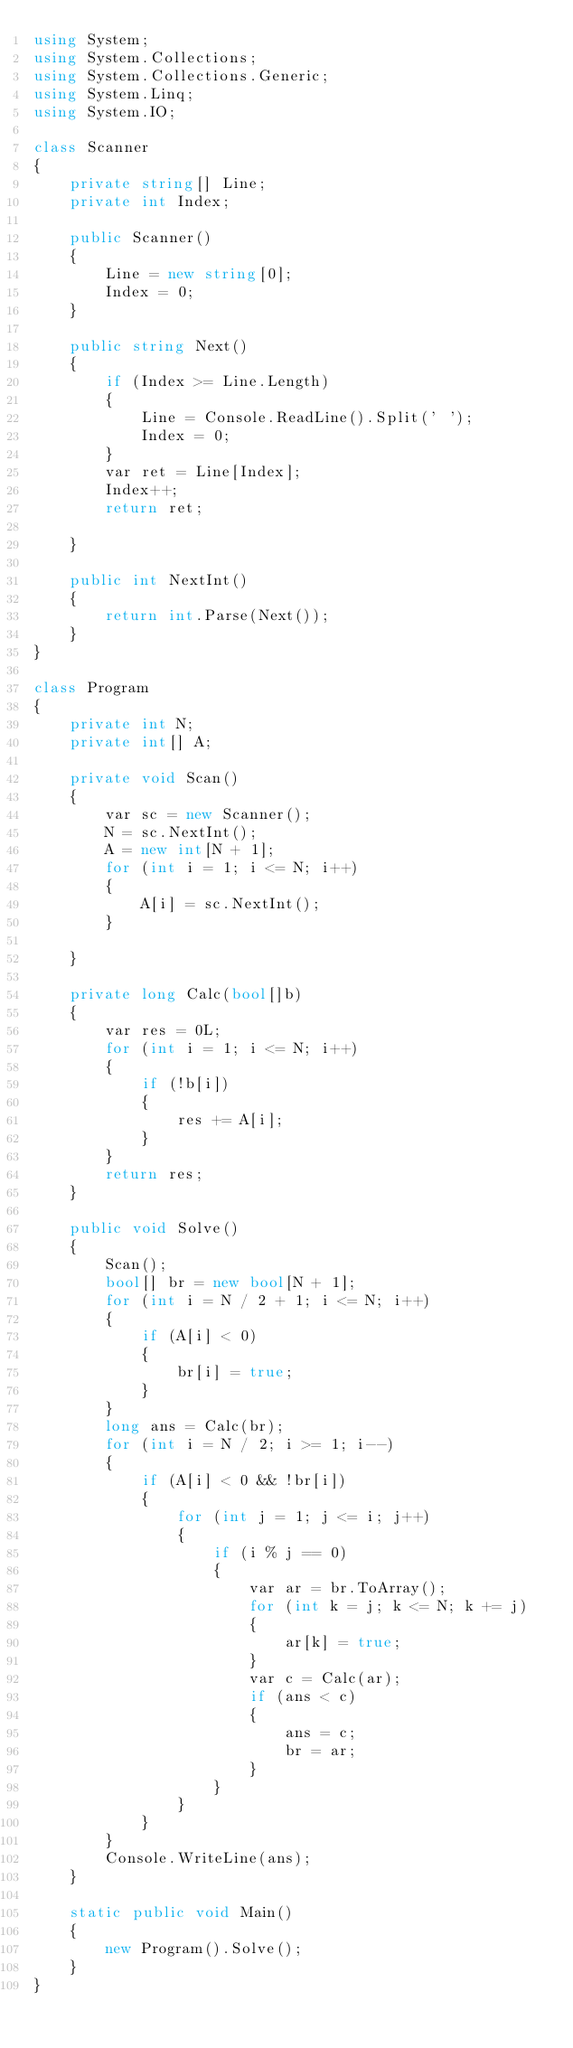<code> <loc_0><loc_0><loc_500><loc_500><_C#_>using System;
using System.Collections;
using System.Collections.Generic;
using System.Linq;
using System.IO;

class Scanner
{
    private string[] Line;
    private int Index;

    public Scanner()
    {
        Line = new string[0];
        Index = 0;
    }

    public string Next()
    {
        if (Index >= Line.Length)
        {
            Line = Console.ReadLine().Split(' ');
            Index = 0;
        }
        var ret = Line[Index];
        Index++;
        return ret;

    }

    public int NextInt()
    {
        return int.Parse(Next());
    }
}

class Program
{
    private int N;
    private int[] A;

    private void Scan()
    {
        var sc = new Scanner();
        N = sc.NextInt();
        A = new int[N + 1];
        for (int i = 1; i <= N; i++)
        {
            A[i] = sc.NextInt();
        }

    }

    private long Calc(bool[]b)
    {
        var res = 0L;
        for (int i = 1; i <= N; i++)
        {
            if (!b[i])
            {
                res += A[i];
            }
        }
        return res;
    }

    public void Solve()
    {
        Scan();
        bool[] br = new bool[N + 1];
        for (int i = N / 2 + 1; i <= N; i++)
        {
            if (A[i] < 0)
            {
                br[i] = true;
            }
        }
        long ans = Calc(br);
        for (int i = N / 2; i >= 1; i--)
        {
            if (A[i] < 0 && !br[i])
            {
                for (int j = 1; j <= i; j++)
                {
                    if (i % j == 0)
                    {
                        var ar = br.ToArray();
                        for (int k = j; k <= N; k += j)
                        {
                            ar[k] = true;   
                        }
                        var c = Calc(ar);
                        if (ans < c)
                        {
                            ans = c;
                            br = ar;
                        }
                    }
                }
            }
        }
        Console.WriteLine(ans);
    }

    static public void Main()
    {
        new Program().Solve();
    }
}</code> 